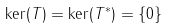<formula> <loc_0><loc_0><loc_500><loc_500>\ker ( T ) = \ker ( T ^ { * } ) = \{ 0 \}</formula> 